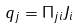<formula> <loc_0><loc_0><loc_500><loc_500>q _ { j } = \Pi _ { j i } J _ { i }</formula> 